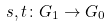<formula> <loc_0><loc_0><loc_500><loc_500>s , t \colon G _ { 1 } \to G _ { 0 }</formula> 